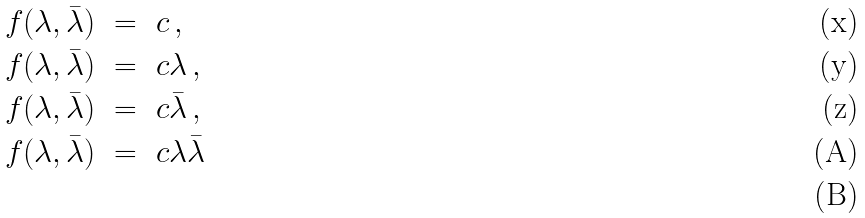<formula> <loc_0><loc_0><loc_500><loc_500>f ( \lambda , \bar { \lambda } ) \ & = \ c \, , \\ f ( \lambda , \bar { \lambda } ) \ & = \ c \lambda \, , \\ f ( \lambda , \bar { \lambda } ) \ & = \ c \bar { \lambda } \, , \\ f ( \lambda , \bar { \lambda } ) \ & = \ c \lambda \bar { \lambda } \, \\</formula> 